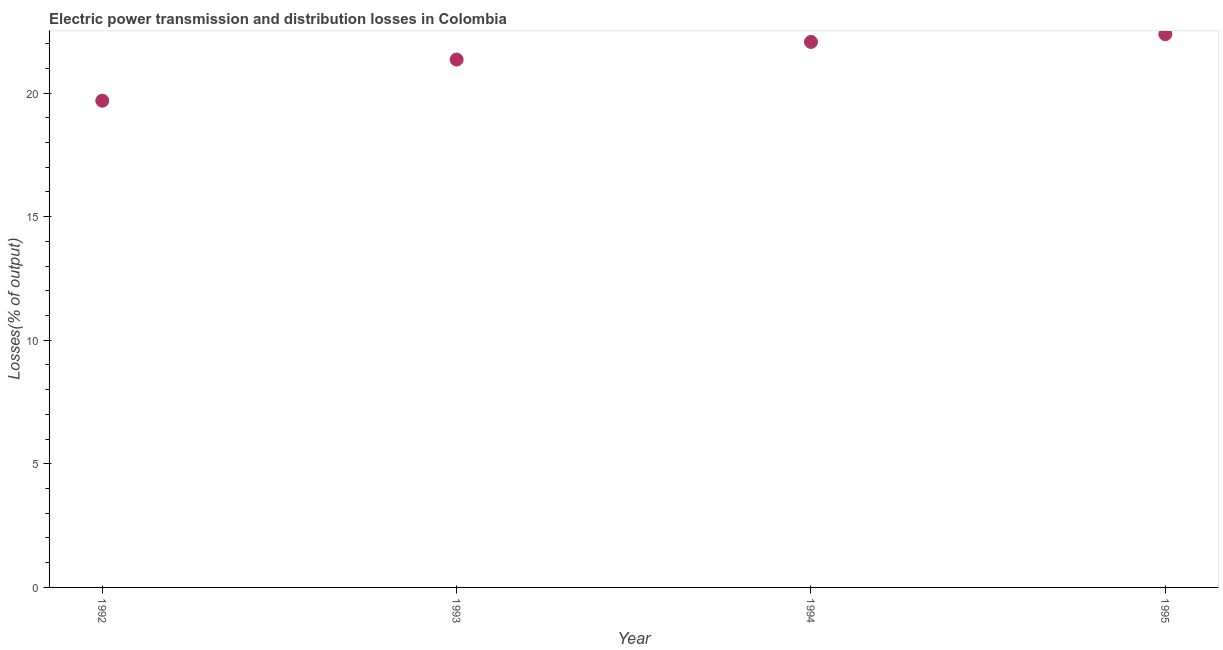What is the electric power transmission and distribution losses in 1992?
Offer a very short reply. 19.69. Across all years, what is the maximum electric power transmission and distribution losses?
Offer a terse response. 22.38. Across all years, what is the minimum electric power transmission and distribution losses?
Your response must be concise. 19.69. In which year was the electric power transmission and distribution losses maximum?
Provide a succinct answer. 1995. In which year was the electric power transmission and distribution losses minimum?
Keep it short and to the point. 1992. What is the sum of the electric power transmission and distribution losses?
Offer a very short reply. 85.5. What is the difference between the electric power transmission and distribution losses in 1994 and 1995?
Your answer should be compact. -0.32. What is the average electric power transmission and distribution losses per year?
Make the answer very short. 21.37. What is the median electric power transmission and distribution losses?
Provide a succinct answer. 21.71. Do a majority of the years between 1995 and 1993 (inclusive) have electric power transmission and distribution losses greater than 15 %?
Your answer should be very brief. No. What is the ratio of the electric power transmission and distribution losses in 1992 to that in 1995?
Make the answer very short. 0.88. What is the difference between the highest and the second highest electric power transmission and distribution losses?
Your response must be concise. 0.32. What is the difference between the highest and the lowest electric power transmission and distribution losses?
Provide a succinct answer. 2.69. Does the electric power transmission and distribution losses monotonically increase over the years?
Your answer should be compact. Yes. How many years are there in the graph?
Give a very brief answer. 4. Are the values on the major ticks of Y-axis written in scientific E-notation?
Keep it short and to the point. No. Does the graph contain any zero values?
Your answer should be very brief. No. Does the graph contain grids?
Your response must be concise. No. What is the title of the graph?
Offer a very short reply. Electric power transmission and distribution losses in Colombia. What is the label or title of the Y-axis?
Provide a succinct answer. Losses(% of output). What is the Losses(% of output) in 1992?
Provide a succinct answer. 19.69. What is the Losses(% of output) in 1993?
Offer a very short reply. 21.35. What is the Losses(% of output) in 1994?
Provide a short and direct response. 22.07. What is the Losses(% of output) in 1995?
Your answer should be very brief. 22.38. What is the difference between the Losses(% of output) in 1992 and 1993?
Your response must be concise. -1.66. What is the difference between the Losses(% of output) in 1992 and 1994?
Offer a terse response. -2.38. What is the difference between the Losses(% of output) in 1992 and 1995?
Your answer should be very brief. -2.69. What is the difference between the Losses(% of output) in 1993 and 1994?
Offer a very short reply. -0.71. What is the difference between the Losses(% of output) in 1993 and 1995?
Provide a short and direct response. -1.03. What is the difference between the Losses(% of output) in 1994 and 1995?
Your answer should be very brief. -0.32. What is the ratio of the Losses(% of output) in 1992 to that in 1993?
Your answer should be very brief. 0.92. What is the ratio of the Losses(% of output) in 1992 to that in 1994?
Offer a very short reply. 0.89. What is the ratio of the Losses(% of output) in 1993 to that in 1994?
Your answer should be very brief. 0.97. What is the ratio of the Losses(% of output) in 1993 to that in 1995?
Give a very brief answer. 0.95. What is the ratio of the Losses(% of output) in 1994 to that in 1995?
Offer a terse response. 0.99. 